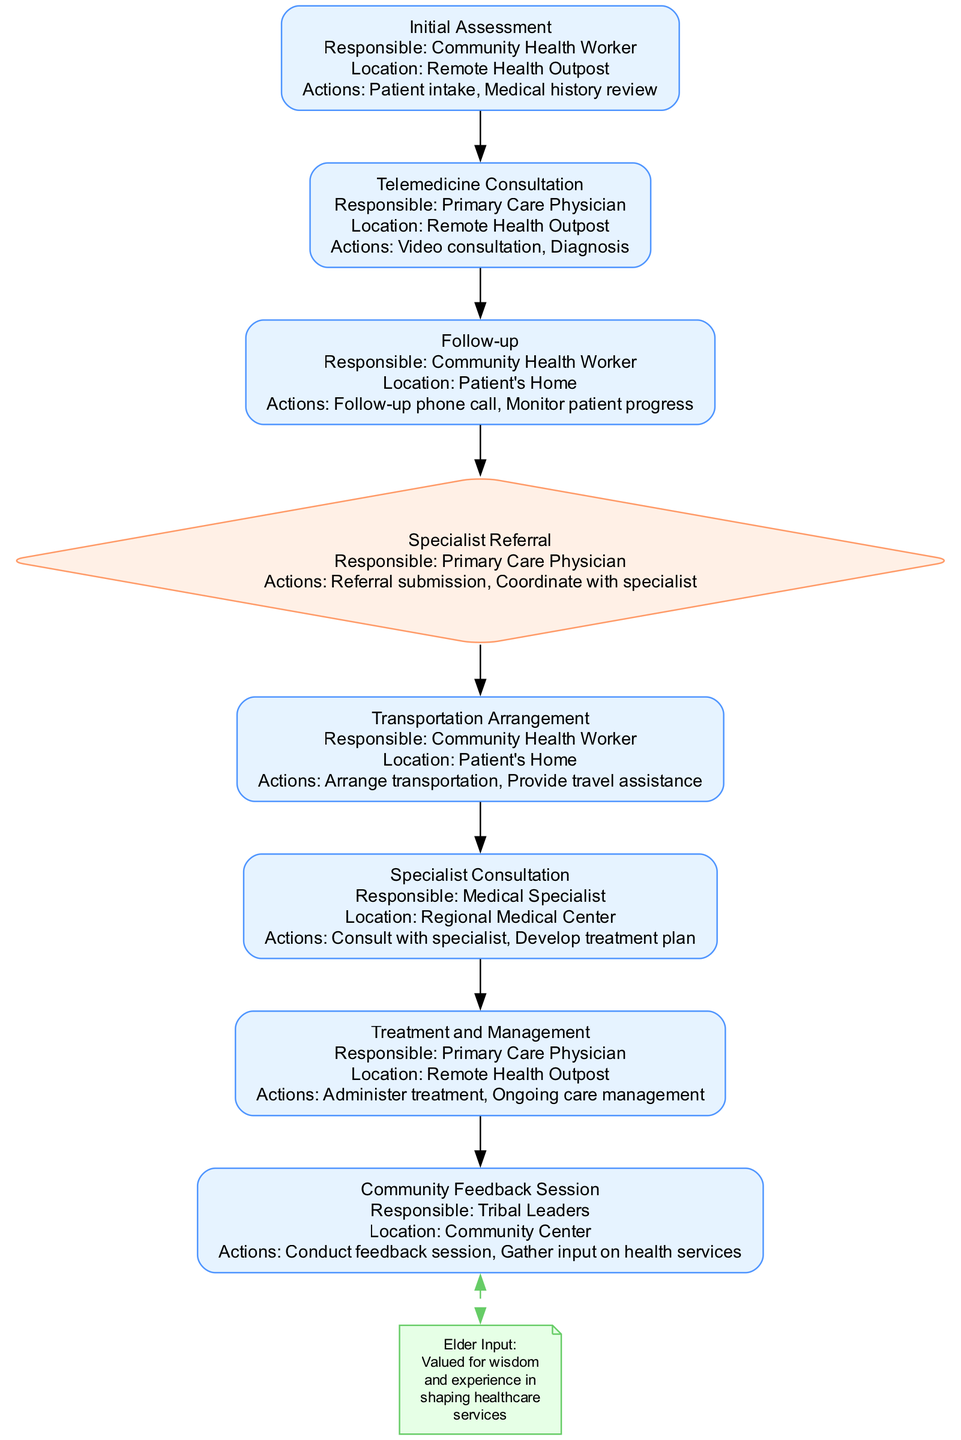What is the first step in the pathway? The first step is labeled "Initial Assessment," which includes actions like patient intake and medical history review, handled by a Community Health Worker at a Remote Health Outpost.
Answer: Initial Assessment Who conducts the "Telemedicine Consultation"? The "Telemedicine Consultation" is conducted by a Primary Care Physician as indicated in the diagram, which specifies their responsibility for this step.
Answer: Primary Care Physician What action is performed during the "Follow-up"? In the "Follow-up" step, actions include a follow-up phone call and monitoring patient progress, which are performed by the Community Health Worker at the patient's home.
Answer: Follow-up phone call, Monitor patient progress What is the criteria for "Specialist Referral"? The criteria for "Specialist Referral" is if the diagnosed condition requires specialist care, as stated in the decision element of the diagram.
Answer: If diagnosed condition requires specialist care What role does the "Community Health Worker" play? The Community Health Worker is responsible for several steps including the Initial Assessment, Follow-up, and Transportation Arrangement, showing their multifaceted role in the pathway.
Answer: Initial Assessment, Follow-up, Transportation Arrangement How many steps are there in the clinical pathway? The clinical pathway consists of six steps in total, excluding the decision point and feedback sessions, which are significant components but not classified as steps.
Answer: Six steps Which location hosts the "Specialist Consultation"? The "Specialist Consultation" takes place at the Regional Medical Center, as specified in the details for this step in the diagram.
Answer: Regional Medical Center What feedback mechanism is included in the pathway? The feedback mechanism included in the pathway is the "Community Feedback Session," which is designated for gathering input on health services from the community.
Answer: Community Feedback Session What is the purpose of the "Elder Input" note? The "Elder Input" note emphasizes the importance of elders' wisdom and experience in shaping healthcare services, highlighting their valued input in the pathway process.
Answer: Valued for wisdom and experience in shaping healthcare services 